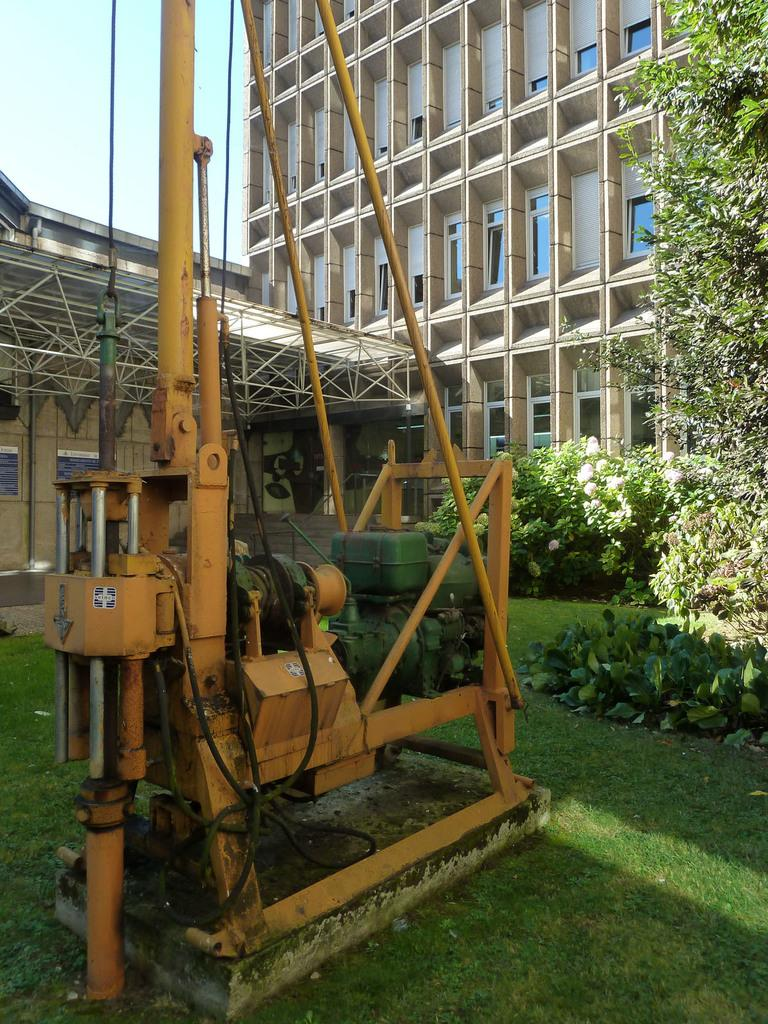What is the main object in the image? There is a machine in the image. Where is the machine located? The machine is on the grass. What can be seen on the right side of the image? There are plants on the right side of the image. What is visible in the background of the image? There are buildings in the background of the image. Can you see the giraffe's hair in the image? There is no giraffe or hair present in the image. 